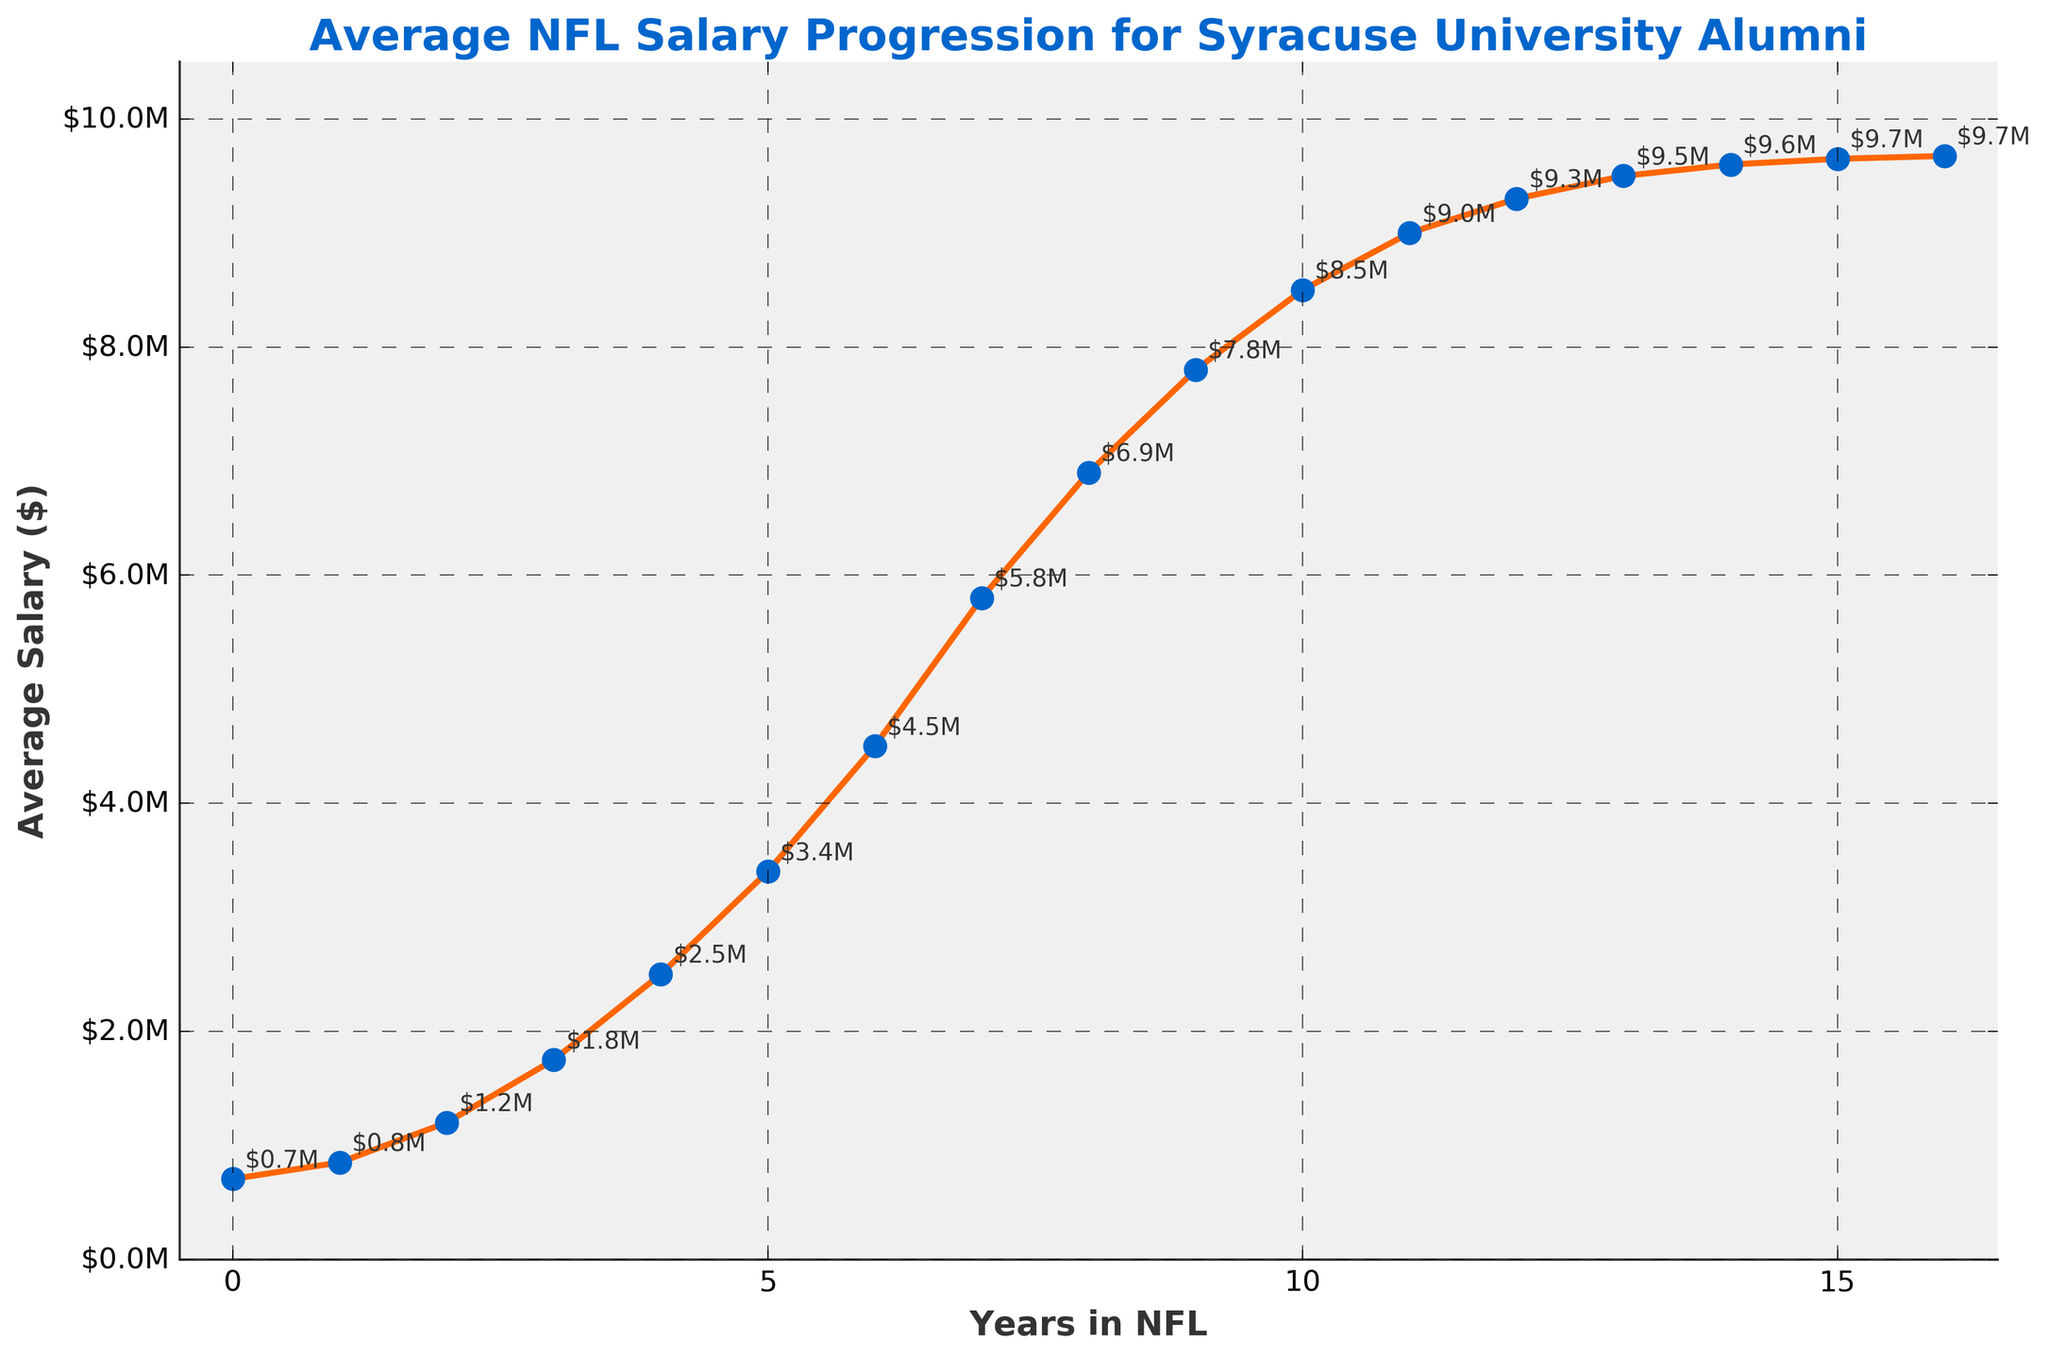what's the average NFL salary progression for Syracuse University alumni in their first three years? The salaries for the first three years are $705,000, $850,000, and $1,200,000. Sum these values and divide by 3: ($705,000 + $850,000 + $1,200,000) / 3 = $2,755,000 / 3 = $918,333.33
Answer: $918,333.33 Which year sees the highest spike in salary for Syracuse University alumni? The steepest increase appears between years 6 and 7, where the salary jumps from $4,500,000 to $5,800,000. The difference is $5,800,000 - $4,500,000 = $1,300,000.
Answer: Year 7 How does the salary in year 10 compare to the salary in year 5? The salary in year 10 is $8,500,000, and in year 5, it is $3,400,000. $8,500,000 is greater than $3,400,000 by $8,500,000 - $3,400,000 = $5,100,000.
Answer: Year 10 is higher by $5,100,000 Is there a year where the salary does not increase or increases by a negligible amount? From year 14 to year 16, the salary only increases marginally from $9,600,000 to $9,675,000, an increase of $75,000.
Answer: Year 14 to 16 What's the total cumulative salary over the first five years? The salaries for the first five years are $705,000, $850,000, $1,200,000, $1,750,000, and $2,500,000. Adding these together: $705,000 + $850,000 + $1,200,000 + $1,750,000 + $2,500,000 = $7,005,000.
Answer: $7,005,000 By how much does the salary increase between the rookie year and retirement? The salary in the rookie year is $705,000 and in year 16 is $9,675,000. The difference: $9,675,000 - $705,000 = $8,970,000.
Answer: $8,970,000 Which color represents the line and data points on the graph? The line is orange and the data points are blue.
Answer: Orange line and blue data points 